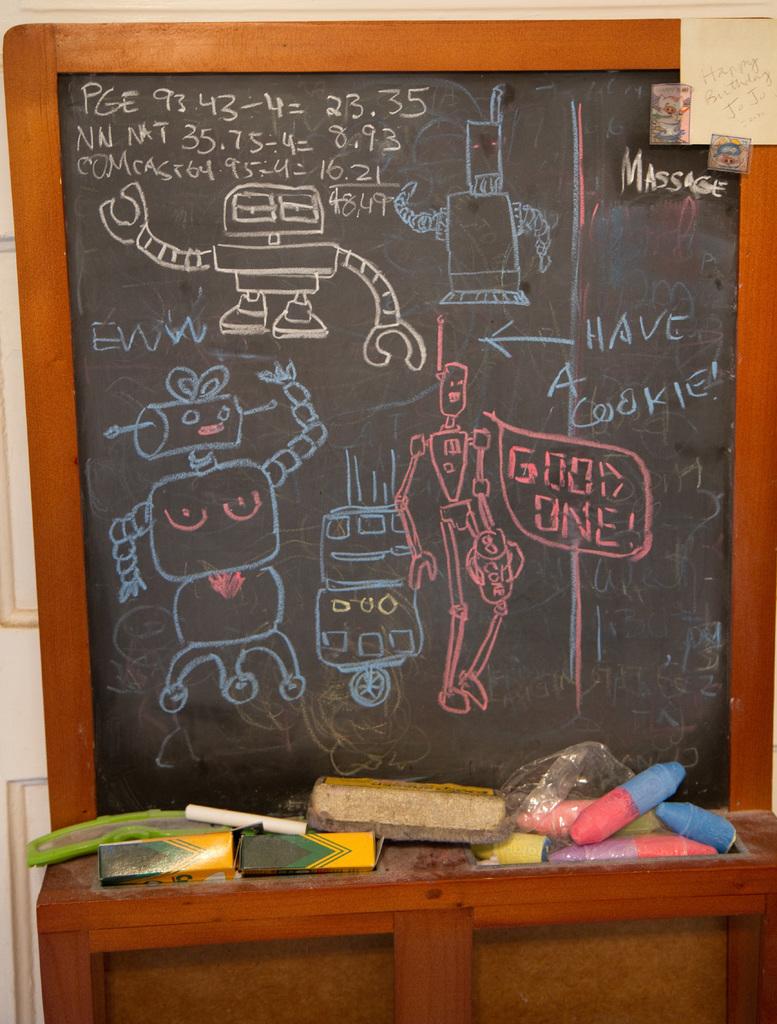What does it say next to the blue arrow?
Give a very brief answer. Have a cookie. What did the pink robot say?
Your response must be concise. Good one. 